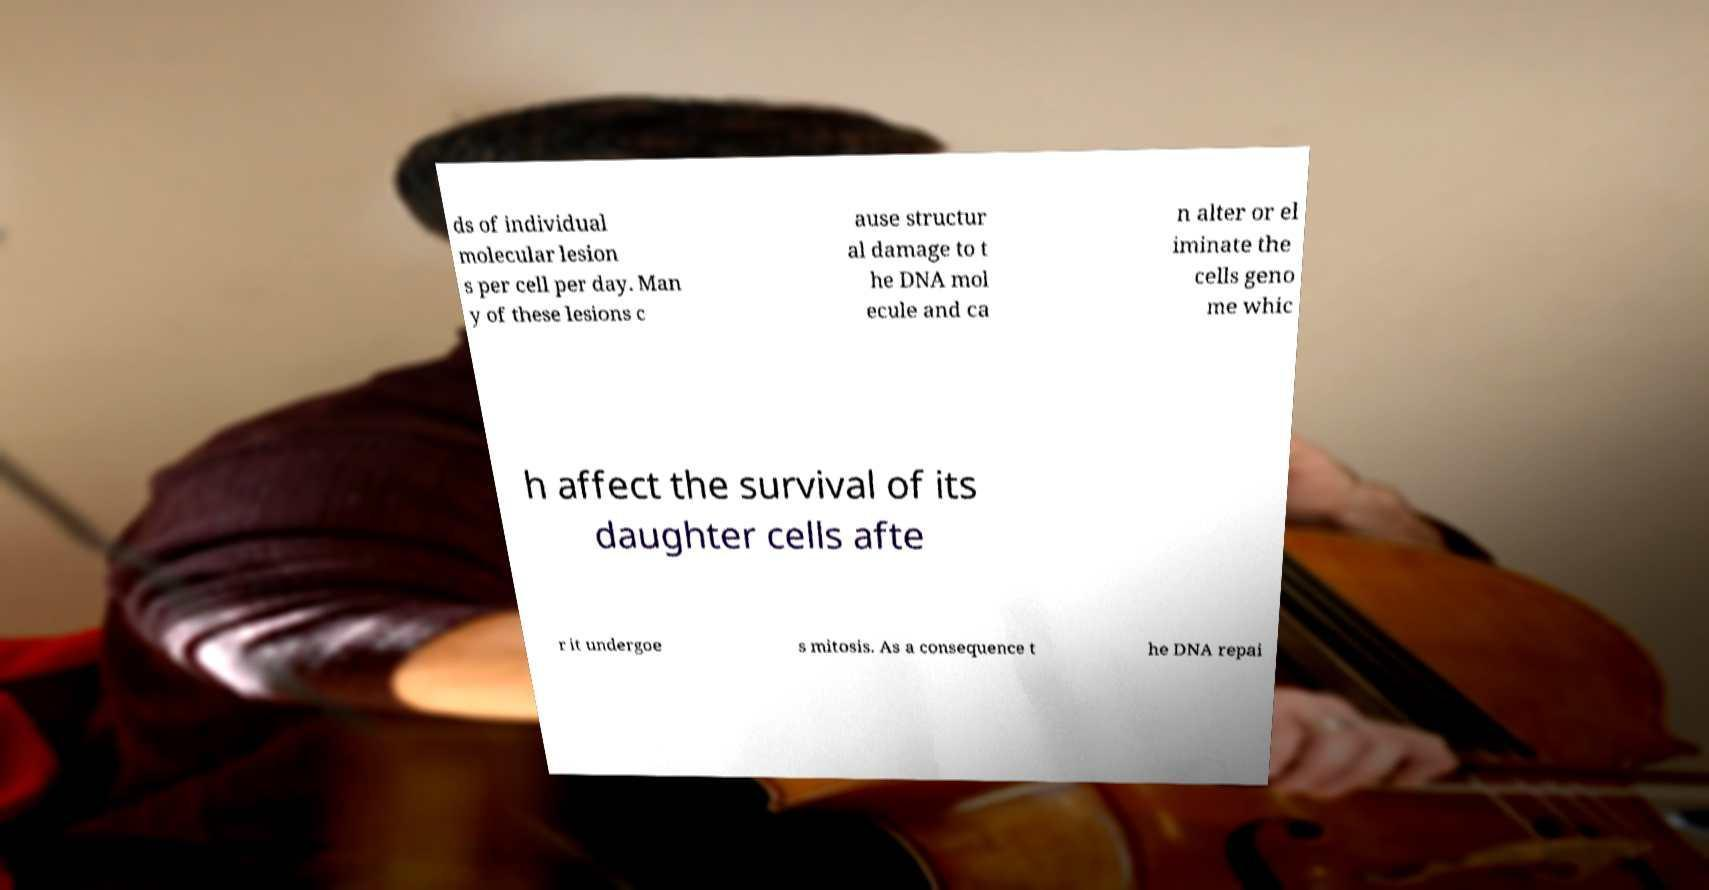There's text embedded in this image that I need extracted. Can you transcribe it verbatim? ds of individual molecular lesion s per cell per day. Man y of these lesions c ause structur al damage to t he DNA mol ecule and ca n alter or el iminate the cells geno me whic h affect the survival of its daughter cells afte r it undergoe s mitosis. As a consequence t he DNA repai 